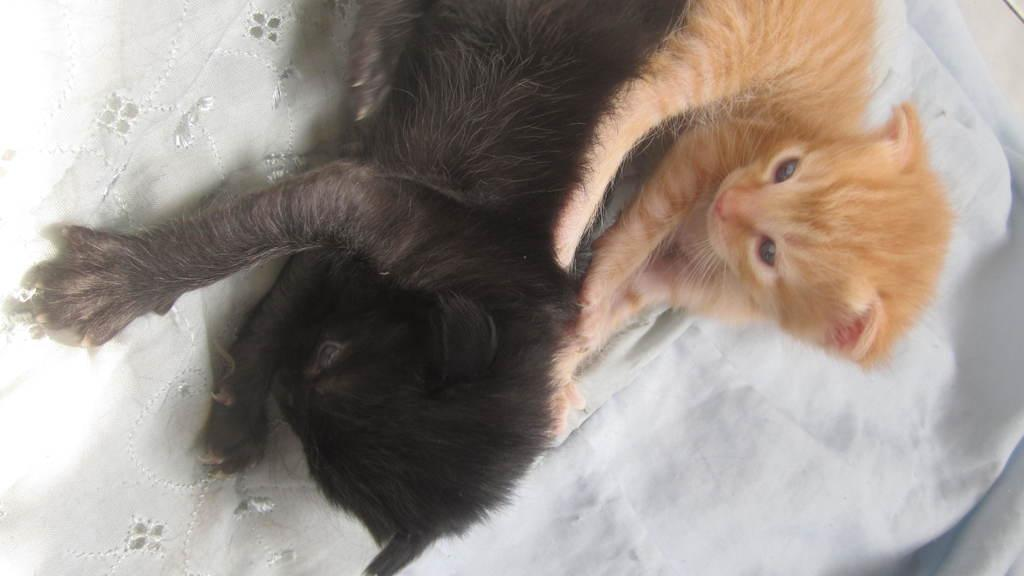How many cats can be seen in the image? There are two cats in the image. What are the cats sitting on? The cats are on a cloth. Is there a volcano erupting in the background of the image? No, there is no volcano or any indication of an eruption in the image. How many kittens are present in the image? There are no kittens mentioned or visible in the image; only two adult cats are present. 